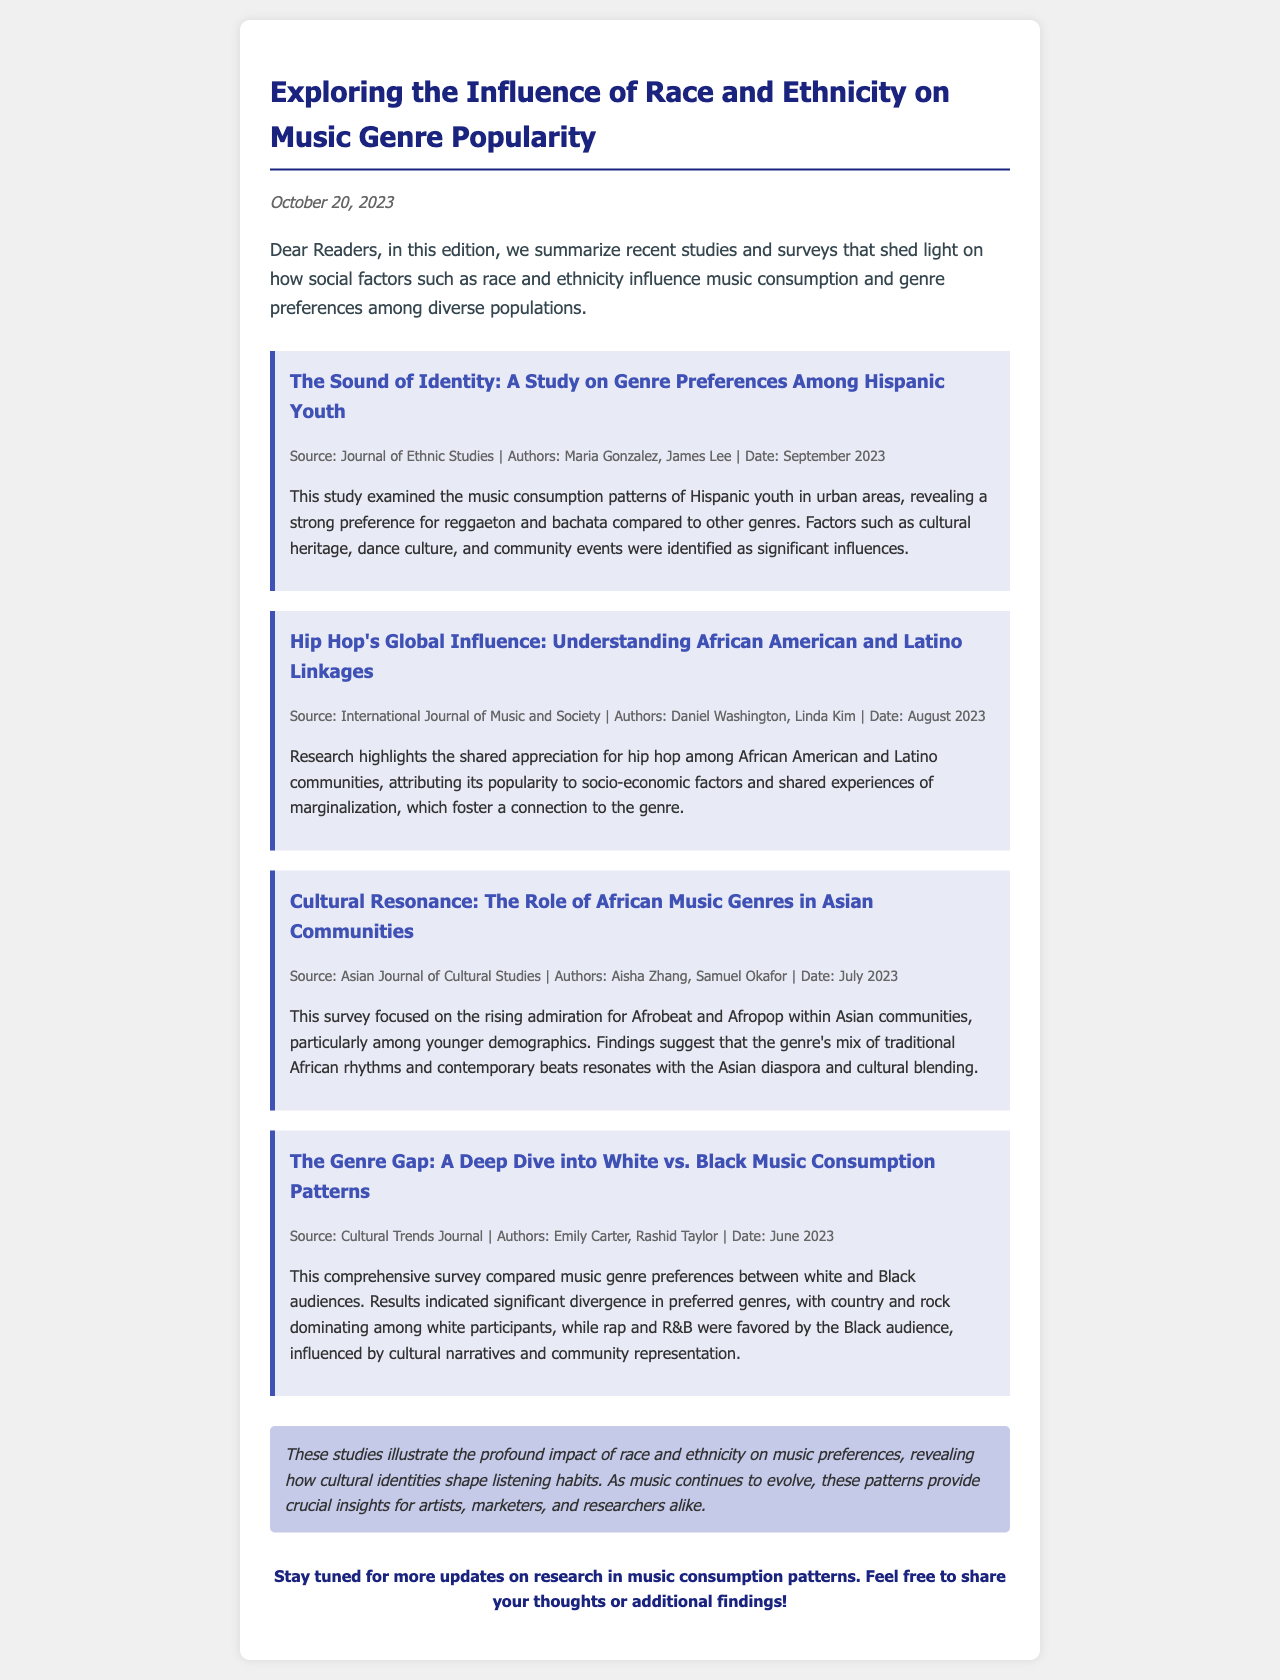What is the title of the newsletter? The title of the newsletter is mentioned at the top of the document.
Answer: Exploring the Influence of Race and Ethnicity on Music Genre Popularity Who are the authors of the study on genre preferences among Hispanic youth? The authors are listed in the study section of the newsletter.
Answer: Maria Gonzalez, James Lee What genre is highlighted in the study about African American and Latino communities? The highlighted genre is specified in the title and description of the study.
Answer: Hip hop What month was the study on the role of African music genres in Asian communities published? The publication date is included in the study information section.
Answer: July How many studies are summarized in the newsletter? The number of studies can be counted from the main content of the document.
Answer: Four Which genre dominated among white participants according to the survey? The survey results are detailed in the last study section.
Answer: Country Why do younger demographics admire Afrobeat and Afropop? The reasoning behind the admiration is explained in the study's findings.
Answer: Cultural blending What is the publication source for the study on the genre gap? The publication source is given in the study information.
Answer: Cultural Trends Journal Who authored the study on the shared appreciation for hip hop? The author names are provided in the study section.
Answer: Daniel Washington, Linda Kim 